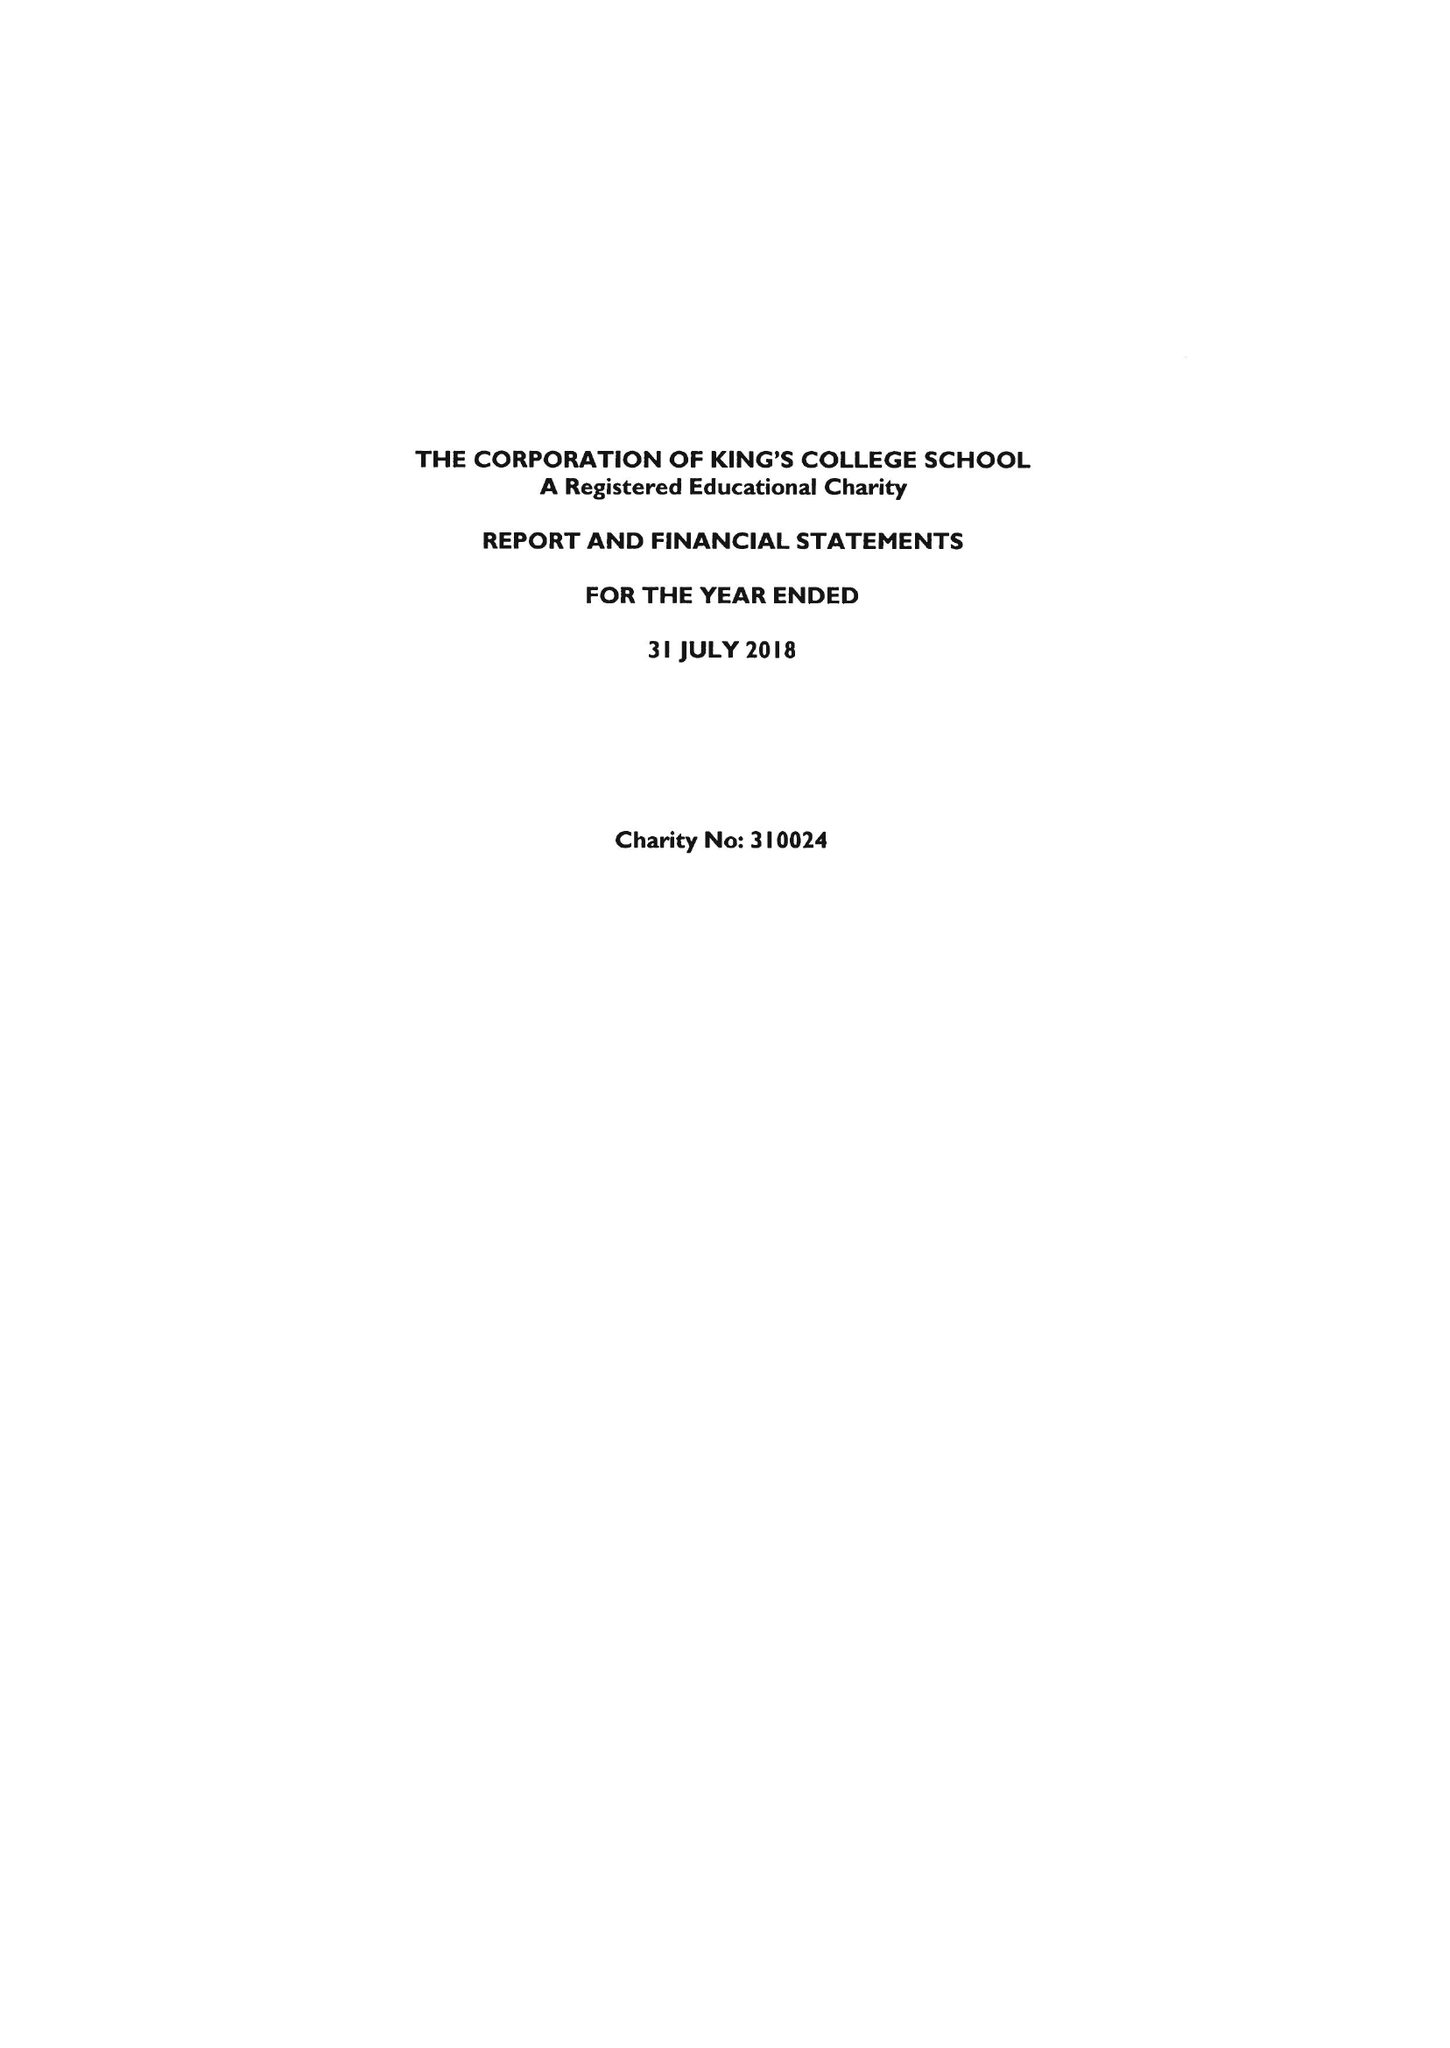What is the value for the report_date?
Answer the question using a single word or phrase. 2018-07-31 